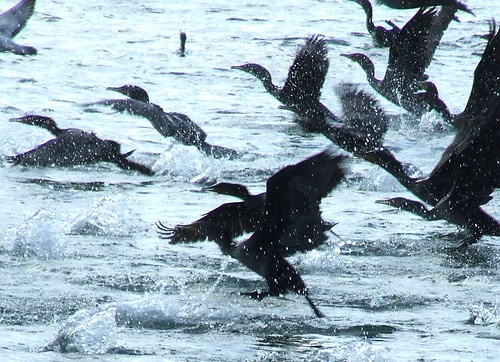Describe the objects in this image and their specific colors. I can see bird in lightblue, black, gray, and blue tones, bird in lightblue, black, gray, and blue tones, bird in lightblue, black, gray, and purple tones, bird in lightblue, black, gray, and blue tones, and bird in lightblue, black, gray, and blue tones in this image. 